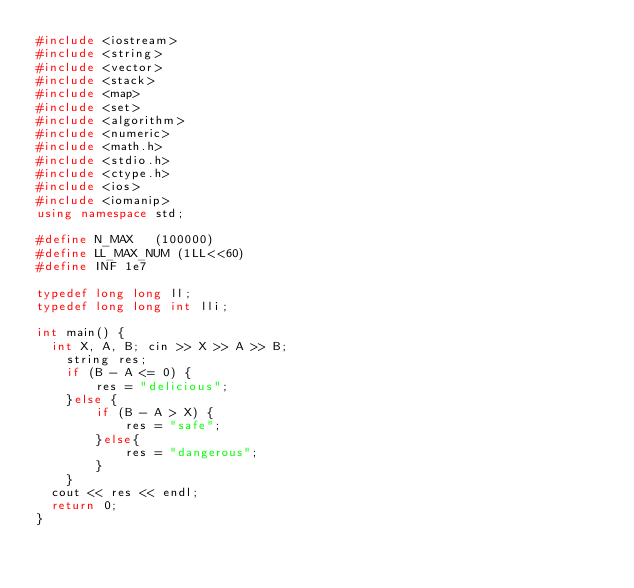Convert code to text. <code><loc_0><loc_0><loc_500><loc_500><_C++_>#include <iostream>
#include <string>
#include <vector>
#include <stack>
#include <map>
#include <set>
#include <algorithm>
#include <numeric>
#include <math.h>
#include <stdio.h>
#include <ctype.h>
#include <ios> 
#include <iomanip>
using namespace std;

#define N_MAX   (100000)
#define LL_MAX_NUM (1LL<<60)
#define INF 1e7

typedef long long ll;
typedef long long int lli;

int main() {
	int X, A, B; cin >> X >> A >> B;
    string res;
    if (B - A <= 0) {
        res = "delicious";
    }else {
        if (B - A > X) {
            res = "safe";
        }else{
            res = "dangerous";
        }
    }
	cout << res << endl;
	return 0;
}</code> 